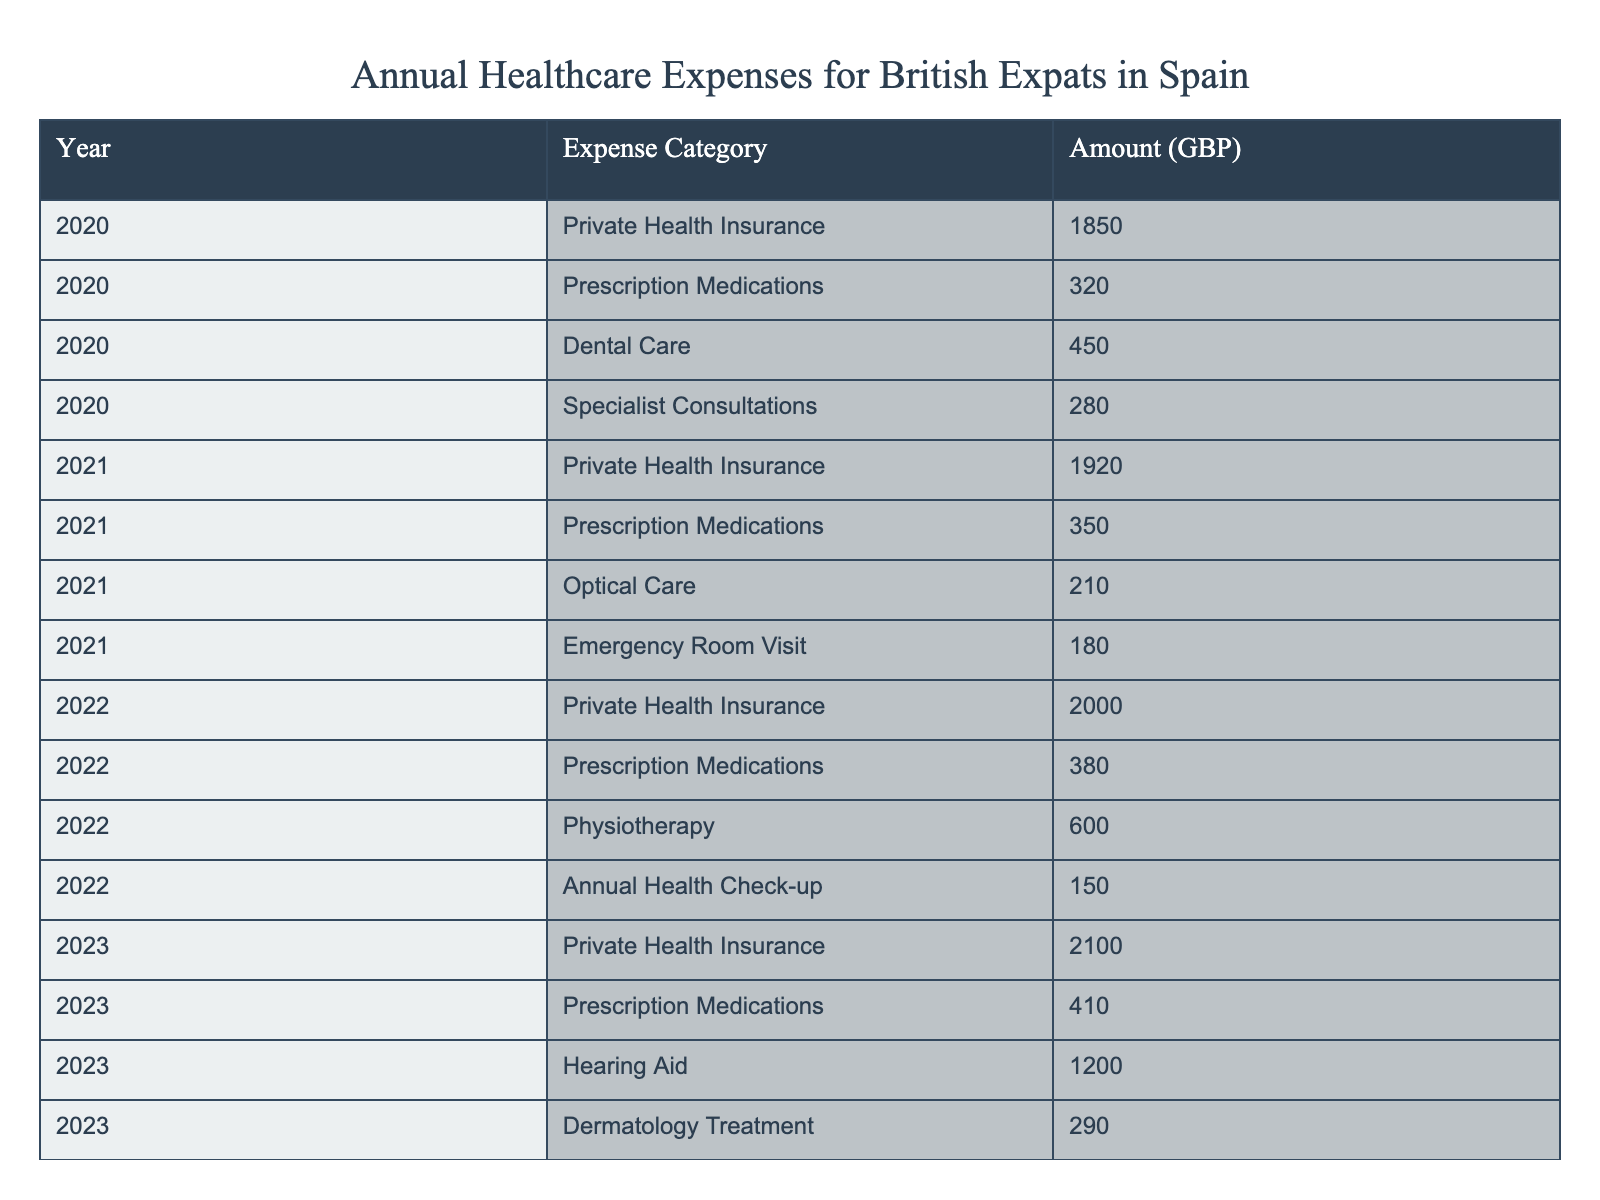What was the total expense for Private Health Insurance in 2022? In 2022, the amount for Private Health Insurance is listed as 2000 GBP.
Answer: 2000 GBP What is the percentage increase in Prescription Medications from 2020 to 2023? The amount for Prescription Medications in 2020 is 320 GBP, and in 2023 it is 410 GBP. The increase is 410 - 320 = 90 GBP. To find the percentage increase, divide 90 by 320 and multiply by 100, which gives (90/320) * 100 = 28.125%.
Answer: 28.125% What was the total healthcare expense for the year 2021? The amounts for 2021 are: Private Health Insurance (1920), Prescription Medications (350), Optical Care (210), and Emergency Room Visit (180). Summing these gives 1920 + 350 + 210 + 180 = 2660 GBP.
Answer: 2660 GBP Did the amount spent on Dental Care in 2020 exceed that spent on Optical Care in 2021? The amount for Dental Care in 2020 is 450 GBP, and the amount for Optical Care in 2021 is 210 GBP. Since 450 is greater than 210, the answer is yes.
Answer: Yes What was the average expense for Specialist Consultations, Physiotherapy, and Hearing Aid over the years they were recorded? Specialist Consultations only appears in 2020 with an expense of 280 GBP. Physiotherapy appears in 2022 with 600 GBP. Hearing Aid appears in 2023 at 1200 GBP. The average is (280 + 600 + 1200) / 3 = 368.67 GBP.
Answer: 368.67 GBP Which expense category saw the highest amount in 2023, and what was that amount? In 2023, the expense amounts are: Private Health Insurance (2100), Prescription Medications (410), Hearing Aid (1200), Dermatology Treatment (290). The highest amount is 2100 GBP for Private Health Insurance.
Answer: 2100 GBP By how much did the total expenses for Dental Care and Specialist Consultations in 2020 compare to the expenses for Optical Care and Emergency Room Visit in 2021? The total for Dental Care and Specialist Consultations in 2020 is 450 + 280 = 730 GBP. The total for Optical Care and Emergency Room Visit in 2021 is 210 + 180 = 390 GBP. The difference is 730 - 390 = 340 GBP, meaning Dental and Specialist expenses exceed by 340 GBP.
Answer: 340 GBP What was the trend observed in Private Health Insurance expenses from 2020 to 2023? The amounts for Private Health Insurance are 1850 in 2020, 1920 in 2021, 2000 in 2022, and 2100 in 2023. All these values show a consistent increase year-on-year.
Answer: Increasing trend 